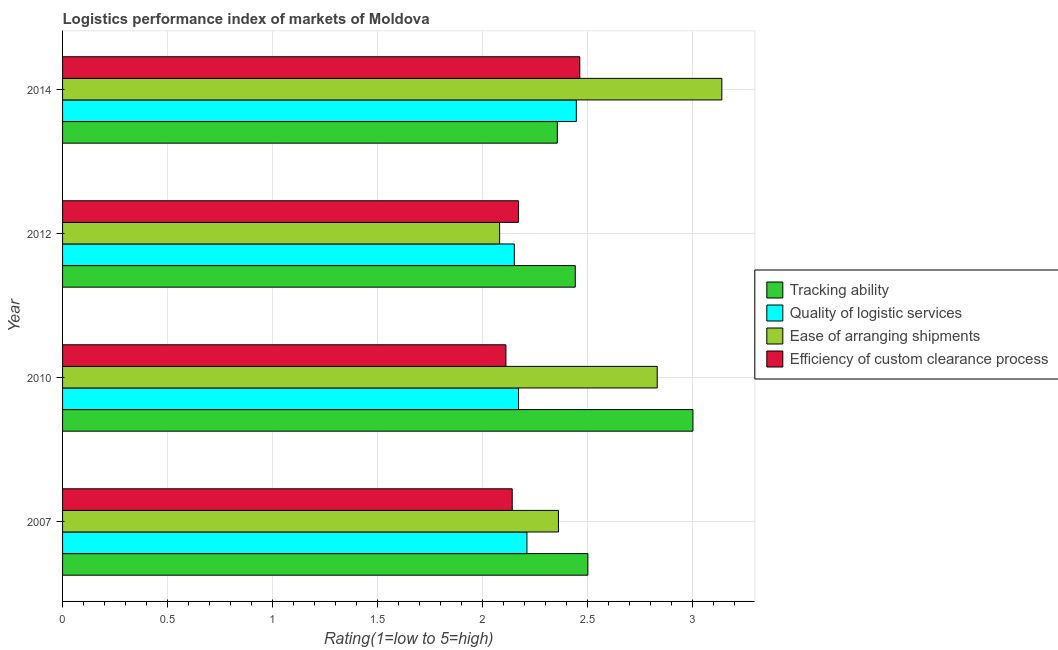How many different coloured bars are there?
Your answer should be compact. 4. Are the number of bars per tick equal to the number of legend labels?
Provide a short and direct response. Yes. How many bars are there on the 4th tick from the top?
Offer a terse response. 4. In how many cases, is the number of bars for a given year not equal to the number of legend labels?
Offer a terse response. 0. What is the lpi rating of efficiency of custom clearance process in 2012?
Offer a terse response. 2.17. Across all years, what is the maximum lpi rating of ease of arranging shipments?
Offer a very short reply. 3.14. Across all years, what is the minimum lpi rating of tracking ability?
Offer a very short reply. 2.35. In which year was the lpi rating of ease of arranging shipments maximum?
Keep it short and to the point. 2014. In which year was the lpi rating of tracking ability minimum?
Your answer should be compact. 2014. What is the total lpi rating of tracking ability in the graph?
Give a very brief answer. 10.29. What is the difference between the lpi rating of tracking ability in 2010 and the lpi rating of efficiency of custom clearance process in 2014?
Offer a terse response. 0.54. What is the average lpi rating of ease of arranging shipments per year?
Offer a very short reply. 2.6. In the year 2010, what is the difference between the lpi rating of efficiency of custom clearance process and lpi rating of ease of arranging shipments?
Your answer should be compact. -0.72. In how many years, is the lpi rating of ease of arranging shipments greater than 0.4 ?
Offer a very short reply. 4. What is the ratio of the lpi rating of tracking ability in 2012 to that in 2014?
Offer a terse response. 1.04. Is the lpi rating of quality of logistic services in 2010 less than that in 2014?
Your response must be concise. Yes. Is the difference between the lpi rating of efficiency of custom clearance process in 2012 and 2014 greater than the difference between the lpi rating of ease of arranging shipments in 2012 and 2014?
Keep it short and to the point. Yes. What is the difference between the highest and the second highest lpi rating of efficiency of custom clearance process?
Your answer should be compact. 0.29. What is the difference between the highest and the lowest lpi rating of ease of arranging shipments?
Your answer should be compact. 1.06. In how many years, is the lpi rating of quality of logistic services greater than the average lpi rating of quality of logistic services taken over all years?
Ensure brevity in your answer.  1. Is the sum of the lpi rating of ease of arranging shipments in 2007 and 2012 greater than the maximum lpi rating of tracking ability across all years?
Ensure brevity in your answer.  Yes. Is it the case that in every year, the sum of the lpi rating of tracking ability and lpi rating of ease of arranging shipments is greater than the sum of lpi rating of quality of logistic services and lpi rating of efficiency of custom clearance process?
Offer a very short reply. No. What does the 1st bar from the top in 2010 represents?
Make the answer very short. Efficiency of custom clearance process. What does the 4th bar from the bottom in 2007 represents?
Provide a succinct answer. Efficiency of custom clearance process. How many years are there in the graph?
Your response must be concise. 4. Are the values on the major ticks of X-axis written in scientific E-notation?
Your answer should be very brief. No. Does the graph contain any zero values?
Give a very brief answer. No. Where does the legend appear in the graph?
Give a very brief answer. Center right. How are the legend labels stacked?
Your answer should be compact. Vertical. What is the title of the graph?
Offer a very short reply. Logistics performance index of markets of Moldova. What is the label or title of the X-axis?
Your answer should be compact. Rating(1=low to 5=high). What is the label or title of the Y-axis?
Ensure brevity in your answer.  Year. What is the Rating(1=low to 5=high) of Tracking ability in 2007?
Make the answer very short. 2.5. What is the Rating(1=low to 5=high) in Quality of logistic services in 2007?
Give a very brief answer. 2.21. What is the Rating(1=low to 5=high) in Ease of arranging shipments in 2007?
Give a very brief answer. 2.36. What is the Rating(1=low to 5=high) of Efficiency of custom clearance process in 2007?
Provide a succinct answer. 2.14. What is the Rating(1=low to 5=high) of Quality of logistic services in 2010?
Your answer should be very brief. 2.17. What is the Rating(1=low to 5=high) in Ease of arranging shipments in 2010?
Give a very brief answer. 2.83. What is the Rating(1=low to 5=high) in Efficiency of custom clearance process in 2010?
Your answer should be compact. 2.11. What is the Rating(1=low to 5=high) of Tracking ability in 2012?
Offer a terse response. 2.44. What is the Rating(1=low to 5=high) in Quality of logistic services in 2012?
Offer a very short reply. 2.15. What is the Rating(1=low to 5=high) of Ease of arranging shipments in 2012?
Make the answer very short. 2.08. What is the Rating(1=low to 5=high) in Efficiency of custom clearance process in 2012?
Your answer should be very brief. 2.17. What is the Rating(1=low to 5=high) in Tracking ability in 2014?
Your response must be concise. 2.35. What is the Rating(1=low to 5=high) of Quality of logistic services in 2014?
Your answer should be compact. 2.44. What is the Rating(1=low to 5=high) in Ease of arranging shipments in 2014?
Provide a succinct answer. 3.14. What is the Rating(1=low to 5=high) in Efficiency of custom clearance process in 2014?
Your response must be concise. 2.46. Across all years, what is the maximum Rating(1=low to 5=high) in Quality of logistic services?
Make the answer very short. 2.44. Across all years, what is the maximum Rating(1=low to 5=high) of Ease of arranging shipments?
Give a very brief answer. 3.14. Across all years, what is the maximum Rating(1=low to 5=high) in Efficiency of custom clearance process?
Your response must be concise. 2.46. Across all years, what is the minimum Rating(1=low to 5=high) of Tracking ability?
Ensure brevity in your answer.  2.35. Across all years, what is the minimum Rating(1=low to 5=high) in Quality of logistic services?
Keep it short and to the point. 2.15. Across all years, what is the minimum Rating(1=low to 5=high) in Ease of arranging shipments?
Provide a short and direct response. 2.08. Across all years, what is the minimum Rating(1=low to 5=high) of Efficiency of custom clearance process?
Give a very brief answer. 2.11. What is the total Rating(1=low to 5=high) of Tracking ability in the graph?
Make the answer very short. 10.29. What is the total Rating(1=low to 5=high) in Quality of logistic services in the graph?
Give a very brief answer. 8.97. What is the total Rating(1=low to 5=high) of Ease of arranging shipments in the graph?
Provide a succinct answer. 10.41. What is the total Rating(1=low to 5=high) of Efficiency of custom clearance process in the graph?
Provide a succinct answer. 8.88. What is the difference between the Rating(1=low to 5=high) in Quality of logistic services in 2007 and that in 2010?
Ensure brevity in your answer.  0.04. What is the difference between the Rating(1=low to 5=high) of Ease of arranging shipments in 2007 and that in 2010?
Your answer should be very brief. -0.47. What is the difference between the Rating(1=low to 5=high) of Quality of logistic services in 2007 and that in 2012?
Your answer should be very brief. 0.06. What is the difference between the Rating(1=low to 5=high) in Ease of arranging shipments in 2007 and that in 2012?
Your answer should be very brief. 0.28. What is the difference between the Rating(1=low to 5=high) in Efficiency of custom clearance process in 2007 and that in 2012?
Make the answer very short. -0.03. What is the difference between the Rating(1=low to 5=high) of Tracking ability in 2007 and that in 2014?
Your response must be concise. 0.15. What is the difference between the Rating(1=low to 5=high) in Quality of logistic services in 2007 and that in 2014?
Your response must be concise. -0.23. What is the difference between the Rating(1=low to 5=high) of Ease of arranging shipments in 2007 and that in 2014?
Give a very brief answer. -0.78. What is the difference between the Rating(1=low to 5=high) of Efficiency of custom clearance process in 2007 and that in 2014?
Make the answer very short. -0.32. What is the difference between the Rating(1=low to 5=high) in Tracking ability in 2010 and that in 2012?
Keep it short and to the point. 0.56. What is the difference between the Rating(1=low to 5=high) of Quality of logistic services in 2010 and that in 2012?
Provide a short and direct response. 0.02. What is the difference between the Rating(1=low to 5=high) in Ease of arranging shipments in 2010 and that in 2012?
Offer a terse response. 0.75. What is the difference between the Rating(1=low to 5=high) of Efficiency of custom clearance process in 2010 and that in 2012?
Your answer should be compact. -0.06. What is the difference between the Rating(1=low to 5=high) of Tracking ability in 2010 and that in 2014?
Offer a terse response. 0.65. What is the difference between the Rating(1=low to 5=high) in Quality of logistic services in 2010 and that in 2014?
Provide a succinct answer. -0.28. What is the difference between the Rating(1=low to 5=high) in Ease of arranging shipments in 2010 and that in 2014?
Make the answer very short. -0.31. What is the difference between the Rating(1=low to 5=high) of Efficiency of custom clearance process in 2010 and that in 2014?
Your response must be concise. -0.35. What is the difference between the Rating(1=low to 5=high) in Tracking ability in 2012 and that in 2014?
Keep it short and to the point. 0.09. What is the difference between the Rating(1=low to 5=high) of Quality of logistic services in 2012 and that in 2014?
Provide a short and direct response. -0.29. What is the difference between the Rating(1=low to 5=high) of Ease of arranging shipments in 2012 and that in 2014?
Provide a short and direct response. -1.06. What is the difference between the Rating(1=low to 5=high) of Efficiency of custom clearance process in 2012 and that in 2014?
Keep it short and to the point. -0.29. What is the difference between the Rating(1=low to 5=high) in Tracking ability in 2007 and the Rating(1=low to 5=high) in Quality of logistic services in 2010?
Your answer should be very brief. 0.33. What is the difference between the Rating(1=low to 5=high) of Tracking ability in 2007 and the Rating(1=low to 5=high) of Ease of arranging shipments in 2010?
Keep it short and to the point. -0.33. What is the difference between the Rating(1=low to 5=high) in Tracking ability in 2007 and the Rating(1=low to 5=high) in Efficiency of custom clearance process in 2010?
Provide a short and direct response. 0.39. What is the difference between the Rating(1=low to 5=high) of Quality of logistic services in 2007 and the Rating(1=low to 5=high) of Ease of arranging shipments in 2010?
Provide a short and direct response. -0.62. What is the difference between the Rating(1=low to 5=high) of Tracking ability in 2007 and the Rating(1=low to 5=high) of Quality of logistic services in 2012?
Provide a succinct answer. 0.35. What is the difference between the Rating(1=low to 5=high) in Tracking ability in 2007 and the Rating(1=low to 5=high) in Ease of arranging shipments in 2012?
Keep it short and to the point. 0.42. What is the difference between the Rating(1=low to 5=high) in Tracking ability in 2007 and the Rating(1=low to 5=high) in Efficiency of custom clearance process in 2012?
Offer a terse response. 0.33. What is the difference between the Rating(1=low to 5=high) in Quality of logistic services in 2007 and the Rating(1=low to 5=high) in Ease of arranging shipments in 2012?
Your response must be concise. 0.13. What is the difference between the Rating(1=low to 5=high) of Ease of arranging shipments in 2007 and the Rating(1=low to 5=high) of Efficiency of custom clearance process in 2012?
Make the answer very short. 0.19. What is the difference between the Rating(1=low to 5=high) in Tracking ability in 2007 and the Rating(1=low to 5=high) in Quality of logistic services in 2014?
Make the answer very short. 0.06. What is the difference between the Rating(1=low to 5=high) of Tracking ability in 2007 and the Rating(1=low to 5=high) of Ease of arranging shipments in 2014?
Offer a very short reply. -0.64. What is the difference between the Rating(1=low to 5=high) in Tracking ability in 2007 and the Rating(1=low to 5=high) in Efficiency of custom clearance process in 2014?
Make the answer very short. 0.04. What is the difference between the Rating(1=low to 5=high) of Quality of logistic services in 2007 and the Rating(1=low to 5=high) of Ease of arranging shipments in 2014?
Ensure brevity in your answer.  -0.93. What is the difference between the Rating(1=low to 5=high) in Quality of logistic services in 2007 and the Rating(1=low to 5=high) in Efficiency of custom clearance process in 2014?
Provide a short and direct response. -0.25. What is the difference between the Rating(1=low to 5=high) in Ease of arranging shipments in 2007 and the Rating(1=low to 5=high) in Efficiency of custom clearance process in 2014?
Your response must be concise. -0.1. What is the difference between the Rating(1=low to 5=high) of Tracking ability in 2010 and the Rating(1=low to 5=high) of Ease of arranging shipments in 2012?
Provide a short and direct response. 0.92. What is the difference between the Rating(1=low to 5=high) of Tracking ability in 2010 and the Rating(1=low to 5=high) of Efficiency of custom clearance process in 2012?
Give a very brief answer. 0.83. What is the difference between the Rating(1=low to 5=high) in Quality of logistic services in 2010 and the Rating(1=low to 5=high) in Ease of arranging shipments in 2012?
Your answer should be very brief. 0.09. What is the difference between the Rating(1=low to 5=high) of Quality of logistic services in 2010 and the Rating(1=low to 5=high) of Efficiency of custom clearance process in 2012?
Make the answer very short. 0. What is the difference between the Rating(1=low to 5=high) of Ease of arranging shipments in 2010 and the Rating(1=low to 5=high) of Efficiency of custom clearance process in 2012?
Ensure brevity in your answer.  0.66. What is the difference between the Rating(1=low to 5=high) in Tracking ability in 2010 and the Rating(1=low to 5=high) in Quality of logistic services in 2014?
Keep it short and to the point. 0.56. What is the difference between the Rating(1=low to 5=high) of Tracking ability in 2010 and the Rating(1=low to 5=high) of Ease of arranging shipments in 2014?
Give a very brief answer. -0.14. What is the difference between the Rating(1=low to 5=high) of Tracking ability in 2010 and the Rating(1=low to 5=high) of Efficiency of custom clearance process in 2014?
Provide a short and direct response. 0.54. What is the difference between the Rating(1=low to 5=high) of Quality of logistic services in 2010 and the Rating(1=low to 5=high) of Ease of arranging shipments in 2014?
Your answer should be compact. -0.97. What is the difference between the Rating(1=low to 5=high) in Quality of logistic services in 2010 and the Rating(1=low to 5=high) in Efficiency of custom clearance process in 2014?
Your response must be concise. -0.29. What is the difference between the Rating(1=low to 5=high) in Ease of arranging shipments in 2010 and the Rating(1=low to 5=high) in Efficiency of custom clearance process in 2014?
Give a very brief answer. 0.37. What is the difference between the Rating(1=low to 5=high) of Tracking ability in 2012 and the Rating(1=low to 5=high) of Quality of logistic services in 2014?
Provide a short and direct response. -0.01. What is the difference between the Rating(1=low to 5=high) of Tracking ability in 2012 and the Rating(1=low to 5=high) of Ease of arranging shipments in 2014?
Make the answer very short. -0.7. What is the difference between the Rating(1=low to 5=high) in Tracking ability in 2012 and the Rating(1=low to 5=high) in Efficiency of custom clearance process in 2014?
Your answer should be very brief. -0.02. What is the difference between the Rating(1=low to 5=high) in Quality of logistic services in 2012 and the Rating(1=low to 5=high) in Ease of arranging shipments in 2014?
Provide a succinct answer. -0.99. What is the difference between the Rating(1=low to 5=high) in Quality of logistic services in 2012 and the Rating(1=low to 5=high) in Efficiency of custom clearance process in 2014?
Your answer should be compact. -0.31. What is the difference between the Rating(1=low to 5=high) in Ease of arranging shipments in 2012 and the Rating(1=low to 5=high) in Efficiency of custom clearance process in 2014?
Keep it short and to the point. -0.38. What is the average Rating(1=low to 5=high) in Tracking ability per year?
Offer a terse response. 2.57. What is the average Rating(1=low to 5=high) of Quality of logistic services per year?
Your answer should be compact. 2.24. What is the average Rating(1=low to 5=high) in Ease of arranging shipments per year?
Make the answer very short. 2.6. What is the average Rating(1=low to 5=high) in Efficiency of custom clearance process per year?
Your answer should be very brief. 2.22. In the year 2007, what is the difference between the Rating(1=low to 5=high) in Tracking ability and Rating(1=low to 5=high) in Quality of logistic services?
Make the answer very short. 0.29. In the year 2007, what is the difference between the Rating(1=low to 5=high) in Tracking ability and Rating(1=low to 5=high) in Ease of arranging shipments?
Provide a succinct answer. 0.14. In the year 2007, what is the difference between the Rating(1=low to 5=high) in Tracking ability and Rating(1=low to 5=high) in Efficiency of custom clearance process?
Offer a terse response. 0.36. In the year 2007, what is the difference between the Rating(1=low to 5=high) in Quality of logistic services and Rating(1=low to 5=high) in Ease of arranging shipments?
Offer a terse response. -0.15. In the year 2007, what is the difference between the Rating(1=low to 5=high) of Quality of logistic services and Rating(1=low to 5=high) of Efficiency of custom clearance process?
Ensure brevity in your answer.  0.07. In the year 2007, what is the difference between the Rating(1=low to 5=high) in Ease of arranging shipments and Rating(1=low to 5=high) in Efficiency of custom clearance process?
Provide a short and direct response. 0.22. In the year 2010, what is the difference between the Rating(1=low to 5=high) of Tracking ability and Rating(1=low to 5=high) of Quality of logistic services?
Keep it short and to the point. 0.83. In the year 2010, what is the difference between the Rating(1=low to 5=high) of Tracking ability and Rating(1=low to 5=high) of Ease of arranging shipments?
Your answer should be very brief. 0.17. In the year 2010, what is the difference between the Rating(1=low to 5=high) in Tracking ability and Rating(1=low to 5=high) in Efficiency of custom clearance process?
Ensure brevity in your answer.  0.89. In the year 2010, what is the difference between the Rating(1=low to 5=high) of Quality of logistic services and Rating(1=low to 5=high) of Ease of arranging shipments?
Your answer should be very brief. -0.66. In the year 2010, what is the difference between the Rating(1=low to 5=high) of Ease of arranging shipments and Rating(1=low to 5=high) of Efficiency of custom clearance process?
Ensure brevity in your answer.  0.72. In the year 2012, what is the difference between the Rating(1=low to 5=high) of Tracking ability and Rating(1=low to 5=high) of Quality of logistic services?
Your answer should be compact. 0.29. In the year 2012, what is the difference between the Rating(1=low to 5=high) of Tracking ability and Rating(1=low to 5=high) of Ease of arranging shipments?
Provide a succinct answer. 0.36. In the year 2012, what is the difference between the Rating(1=low to 5=high) of Tracking ability and Rating(1=low to 5=high) of Efficiency of custom clearance process?
Give a very brief answer. 0.27. In the year 2012, what is the difference between the Rating(1=low to 5=high) of Quality of logistic services and Rating(1=low to 5=high) of Ease of arranging shipments?
Ensure brevity in your answer.  0.07. In the year 2012, what is the difference between the Rating(1=low to 5=high) of Quality of logistic services and Rating(1=low to 5=high) of Efficiency of custom clearance process?
Offer a very short reply. -0.02. In the year 2012, what is the difference between the Rating(1=low to 5=high) of Ease of arranging shipments and Rating(1=low to 5=high) of Efficiency of custom clearance process?
Offer a very short reply. -0.09. In the year 2014, what is the difference between the Rating(1=low to 5=high) in Tracking ability and Rating(1=low to 5=high) in Quality of logistic services?
Your answer should be compact. -0.09. In the year 2014, what is the difference between the Rating(1=low to 5=high) in Tracking ability and Rating(1=low to 5=high) in Ease of arranging shipments?
Your answer should be very brief. -0.78. In the year 2014, what is the difference between the Rating(1=low to 5=high) of Tracking ability and Rating(1=low to 5=high) of Efficiency of custom clearance process?
Make the answer very short. -0.11. In the year 2014, what is the difference between the Rating(1=low to 5=high) of Quality of logistic services and Rating(1=low to 5=high) of Ease of arranging shipments?
Give a very brief answer. -0.69. In the year 2014, what is the difference between the Rating(1=low to 5=high) of Quality of logistic services and Rating(1=low to 5=high) of Efficiency of custom clearance process?
Keep it short and to the point. -0.02. In the year 2014, what is the difference between the Rating(1=low to 5=high) of Ease of arranging shipments and Rating(1=low to 5=high) of Efficiency of custom clearance process?
Provide a short and direct response. 0.68. What is the ratio of the Rating(1=low to 5=high) in Tracking ability in 2007 to that in 2010?
Provide a succinct answer. 0.83. What is the ratio of the Rating(1=low to 5=high) in Quality of logistic services in 2007 to that in 2010?
Offer a terse response. 1.02. What is the ratio of the Rating(1=low to 5=high) in Ease of arranging shipments in 2007 to that in 2010?
Give a very brief answer. 0.83. What is the ratio of the Rating(1=low to 5=high) in Efficiency of custom clearance process in 2007 to that in 2010?
Offer a very short reply. 1.01. What is the ratio of the Rating(1=low to 5=high) of Tracking ability in 2007 to that in 2012?
Offer a very short reply. 1.02. What is the ratio of the Rating(1=low to 5=high) of Quality of logistic services in 2007 to that in 2012?
Offer a very short reply. 1.03. What is the ratio of the Rating(1=low to 5=high) of Ease of arranging shipments in 2007 to that in 2012?
Provide a succinct answer. 1.13. What is the ratio of the Rating(1=low to 5=high) in Efficiency of custom clearance process in 2007 to that in 2012?
Give a very brief answer. 0.99. What is the ratio of the Rating(1=low to 5=high) of Tracking ability in 2007 to that in 2014?
Provide a succinct answer. 1.06. What is the ratio of the Rating(1=low to 5=high) in Quality of logistic services in 2007 to that in 2014?
Keep it short and to the point. 0.9. What is the ratio of the Rating(1=low to 5=high) of Ease of arranging shipments in 2007 to that in 2014?
Offer a very short reply. 0.75. What is the ratio of the Rating(1=low to 5=high) in Efficiency of custom clearance process in 2007 to that in 2014?
Give a very brief answer. 0.87. What is the ratio of the Rating(1=low to 5=high) of Tracking ability in 2010 to that in 2012?
Your answer should be very brief. 1.23. What is the ratio of the Rating(1=low to 5=high) in Quality of logistic services in 2010 to that in 2012?
Your answer should be compact. 1.01. What is the ratio of the Rating(1=low to 5=high) of Ease of arranging shipments in 2010 to that in 2012?
Make the answer very short. 1.36. What is the ratio of the Rating(1=low to 5=high) of Efficiency of custom clearance process in 2010 to that in 2012?
Keep it short and to the point. 0.97. What is the ratio of the Rating(1=low to 5=high) in Tracking ability in 2010 to that in 2014?
Your answer should be very brief. 1.27. What is the ratio of the Rating(1=low to 5=high) in Quality of logistic services in 2010 to that in 2014?
Your response must be concise. 0.89. What is the ratio of the Rating(1=low to 5=high) in Ease of arranging shipments in 2010 to that in 2014?
Offer a terse response. 0.9. What is the ratio of the Rating(1=low to 5=high) of Efficiency of custom clearance process in 2010 to that in 2014?
Your answer should be very brief. 0.86. What is the ratio of the Rating(1=low to 5=high) in Tracking ability in 2012 to that in 2014?
Provide a succinct answer. 1.04. What is the ratio of the Rating(1=low to 5=high) in Quality of logistic services in 2012 to that in 2014?
Ensure brevity in your answer.  0.88. What is the ratio of the Rating(1=low to 5=high) in Ease of arranging shipments in 2012 to that in 2014?
Keep it short and to the point. 0.66. What is the ratio of the Rating(1=low to 5=high) of Efficiency of custom clearance process in 2012 to that in 2014?
Offer a terse response. 0.88. What is the difference between the highest and the second highest Rating(1=low to 5=high) of Quality of logistic services?
Keep it short and to the point. 0.23. What is the difference between the highest and the second highest Rating(1=low to 5=high) in Ease of arranging shipments?
Make the answer very short. 0.31. What is the difference between the highest and the second highest Rating(1=low to 5=high) of Efficiency of custom clearance process?
Ensure brevity in your answer.  0.29. What is the difference between the highest and the lowest Rating(1=low to 5=high) in Tracking ability?
Your response must be concise. 0.65. What is the difference between the highest and the lowest Rating(1=low to 5=high) in Quality of logistic services?
Provide a short and direct response. 0.29. What is the difference between the highest and the lowest Rating(1=low to 5=high) of Ease of arranging shipments?
Keep it short and to the point. 1.06. What is the difference between the highest and the lowest Rating(1=low to 5=high) in Efficiency of custom clearance process?
Offer a terse response. 0.35. 